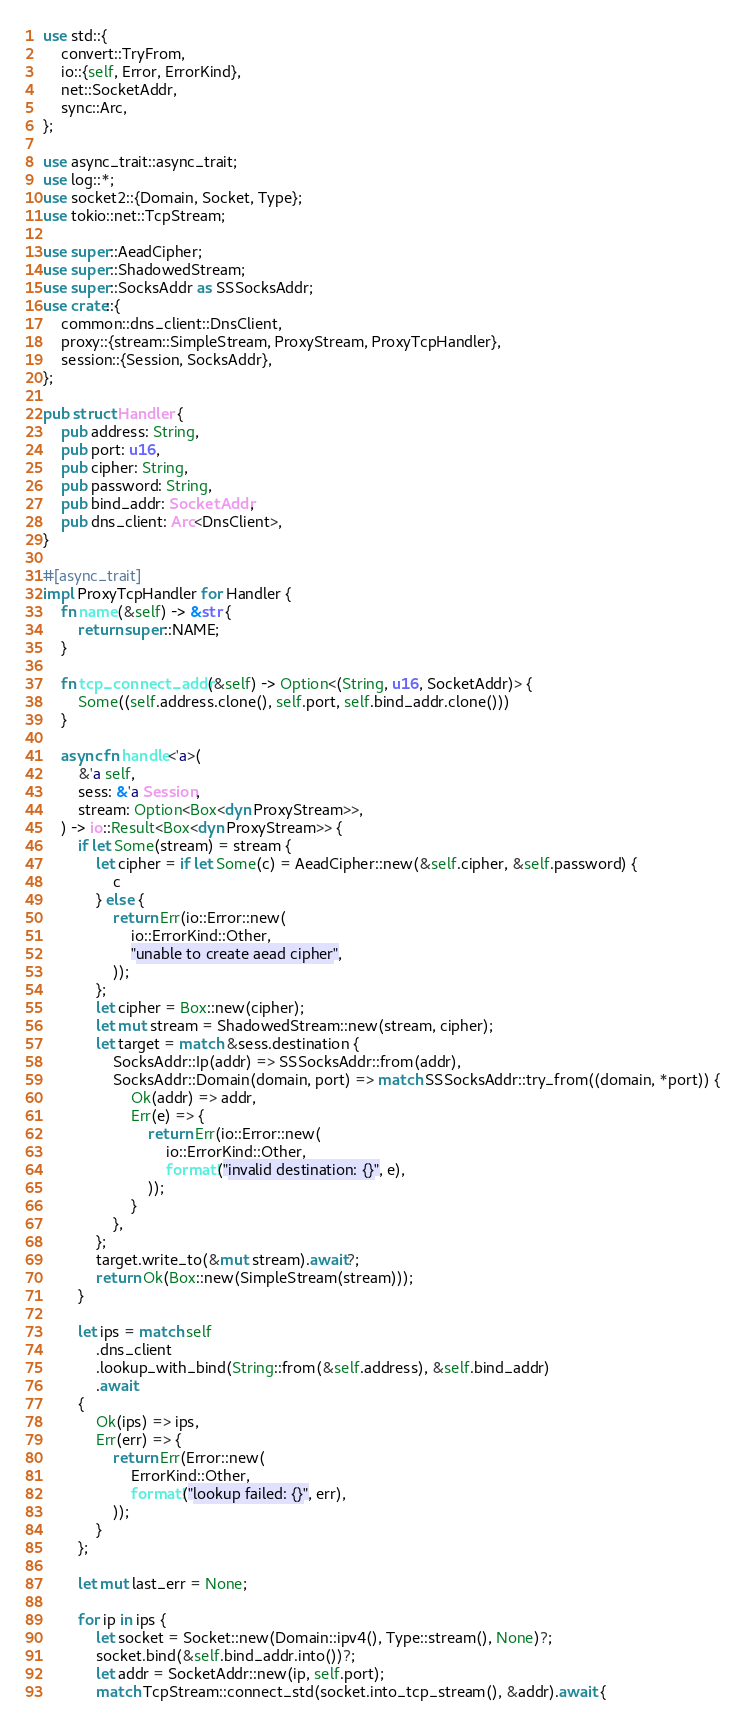<code> <loc_0><loc_0><loc_500><loc_500><_Rust_>use std::{
    convert::TryFrom,
    io::{self, Error, ErrorKind},
    net::SocketAddr,
    sync::Arc,
};

use async_trait::async_trait;
use log::*;
use socket2::{Domain, Socket, Type};
use tokio::net::TcpStream;

use super::AeadCipher;
use super::ShadowedStream;
use super::SocksAddr as SSSocksAddr;
use crate::{
    common::dns_client::DnsClient,
    proxy::{stream::SimpleStream, ProxyStream, ProxyTcpHandler},
    session::{Session, SocksAddr},
};

pub struct Handler {
    pub address: String,
    pub port: u16,
    pub cipher: String,
    pub password: String,
    pub bind_addr: SocketAddr,
    pub dns_client: Arc<DnsClient>,
}

#[async_trait]
impl ProxyTcpHandler for Handler {
    fn name(&self) -> &str {
        return super::NAME;
    }

    fn tcp_connect_addr(&self) -> Option<(String, u16, SocketAddr)> {
        Some((self.address.clone(), self.port, self.bind_addr.clone()))
    }

    async fn handle<'a>(
        &'a self,
        sess: &'a Session,
        stream: Option<Box<dyn ProxyStream>>,
    ) -> io::Result<Box<dyn ProxyStream>> {
        if let Some(stream) = stream {
            let cipher = if let Some(c) = AeadCipher::new(&self.cipher, &self.password) {
                c
            } else {
                return Err(io::Error::new(
                    io::ErrorKind::Other,
                    "unable to create aead cipher",
                ));
            };
            let cipher = Box::new(cipher);
            let mut stream = ShadowedStream::new(stream, cipher);
            let target = match &sess.destination {
                SocksAddr::Ip(addr) => SSSocksAddr::from(addr),
                SocksAddr::Domain(domain, port) => match SSSocksAddr::try_from((domain, *port)) {
                    Ok(addr) => addr,
                    Err(e) => {
                        return Err(io::Error::new(
                            io::ErrorKind::Other,
                            format!("invalid destination: {}", e),
                        ));
                    }
                },
            };
            target.write_to(&mut stream).await?;
            return Ok(Box::new(SimpleStream(stream)));
        }

        let ips = match self
            .dns_client
            .lookup_with_bind(String::from(&self.address), &self.bind_addr)
            .await
        {
            Ok(ips) => ips,
            Err(err) => {
                return Err(Error::new(
                    ErrorKind::Other,
                    format!("lookup failed: {}", err),
                ));
            }
        };

        let mut last_err = None;

        for ip in ips {
            let socket = Socket::new(Domain::ipv4(), Type::stream(), None)?;
            socket.bind(&self.bind_addr.into())?;
            let addr = SocketAddr::new(ip, self.port);
            match TcpStream::connect_std(socket.into_tcp_stream(), &addr).await {</code> 